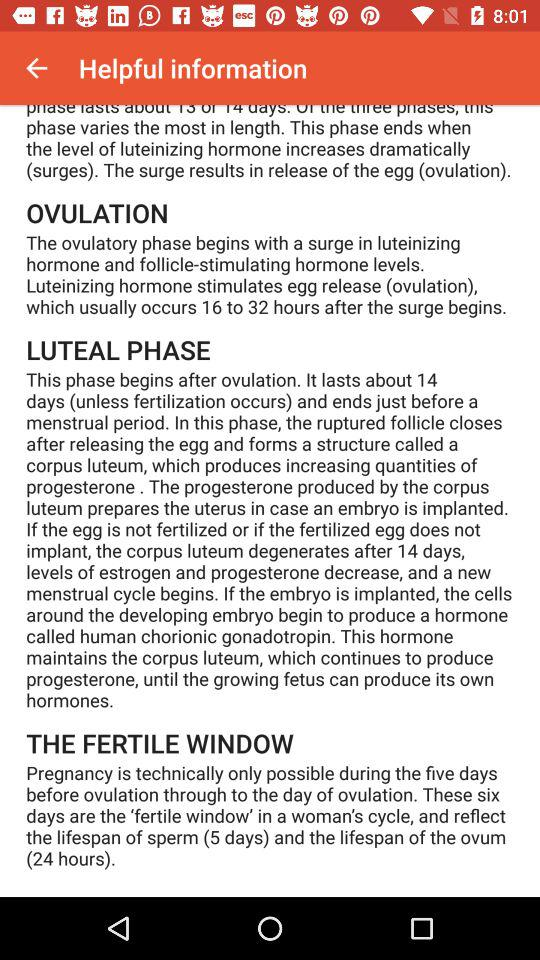How many days are in the fertile window?
Answer the question using a single word or phrase. 6 days 